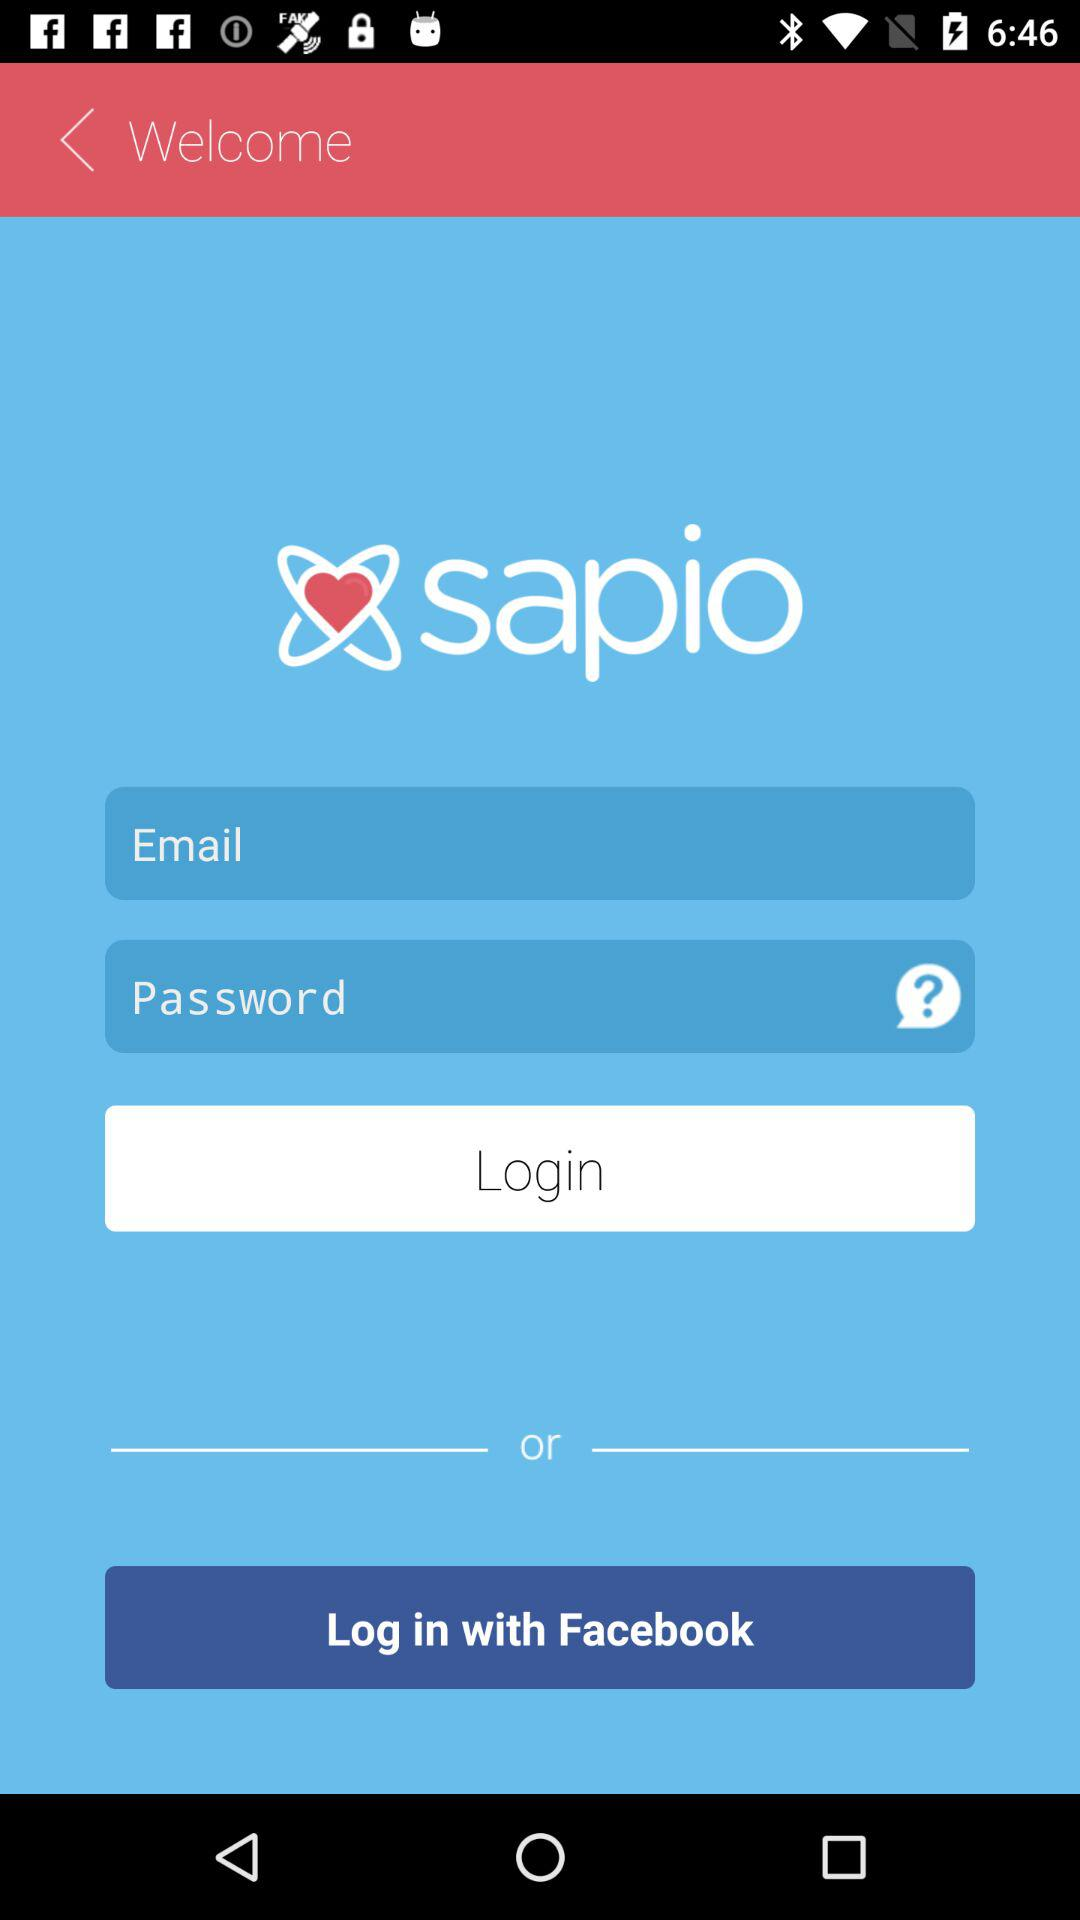What application can be used to log in? The application "Facebook" can be used to log in. 